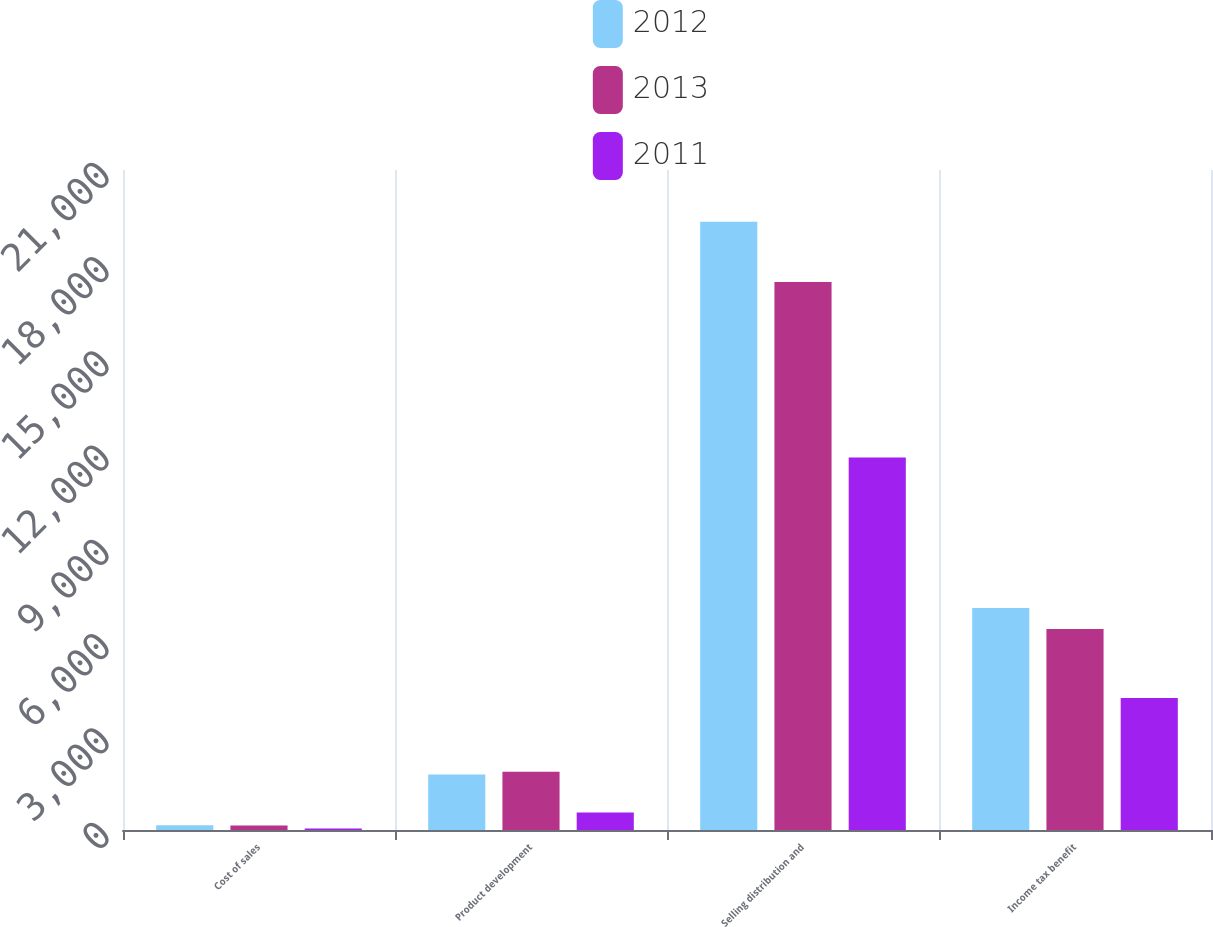Convert chart. <chart><loc_0><loc_0><loc_500><loc_500><stacked_bar_chart><ecel><fcel>Cost of sales<fcel>Product development<fcel>Selling distribution and<fcel>Income tax benefit<nl><fcel>2012<fcel>152<fcel>1767<fcel>19353<fcel>7065<nl><fcel>2013<fcel>146<fcel>1854<fcel>17434<fcel>6392<nl><fcel>2011<fcel>51<fcel>556<fcel>11856<fcel>4202<nl></chart> 